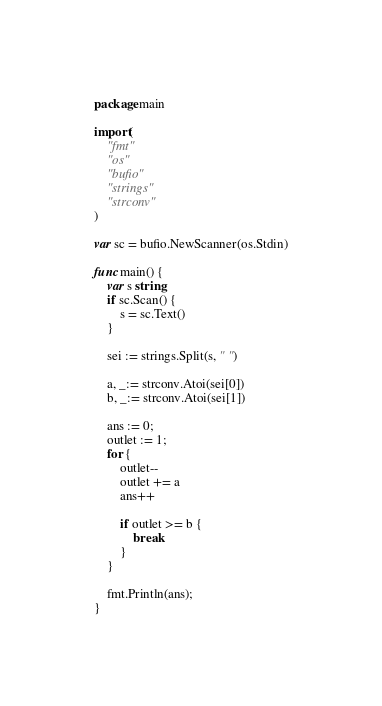<code> <loc_0><loc_0><loc_500><loc_500><_Go_>package main

import(
	"fmt"
	"os"
	"bufio"
	"strings"
	"strconv"
)

var sc = bufio.NewScanner(os.Stdin)

func main() {
	var s string
	if sc.Scan() {
		s = sc.Text()
	}

	sei := strings.Split(s, " ")

	a, _:= strconv.Atoi(sei[0])
	b, _:= strconv.Atoi(sei[1])

	ans := 0;
	outlet := 1;
	for {
		outlet--
		outlet += a
		ans++

		if outlet >= b {
			break
		}
	}

	fmt.Println(ans);
}</code> 